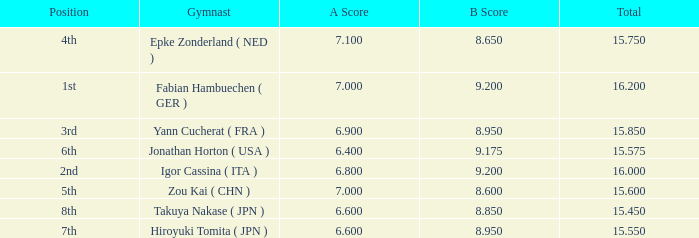Could you parse the entire table as a dict? {'header': ['Position', 'Gymnast', 'A Score', 'B Score', 'Total'], 'rows': [['4th', 'Epke Zonderland ( NED )', '7.100', '8.650', '15.750'], ['1st', 'Fabian Hambuechen ( GER )', '7.000', '9.200', '16.200'], ['3rd', 'Yann Cucherat ( FRA )', '6.900', '8.950', '15.850'], ['6th', 'Jonathan Horton ( USA )', '6.400', '9.175', '15.575'], ['2nd', 'Igor Cassina ( ITA )', '6.800', '9.200', '16.000'], ['5th', 'Zou Kai ( CHN )', '7.000', '8.600', '15.600'], ['8th', 'Takuya Nakase ( JPN )', '6.600', '8.850', '15.450'], ['7th', 'Hiroyuki Tomita ( JPN )', '6.600', '8.950', '15.550']]} What was the total rating that had a score higher than 7 and a b score smaller than 8.65? None. 